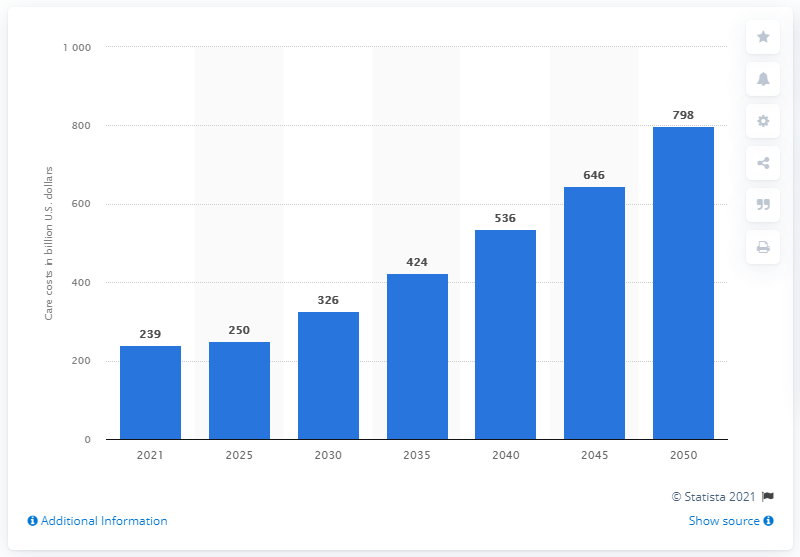Give some essential details in this illustration. In 2021, the cost of Alzheimer's disease to Medicare and Medicaid was $239 billion. By 2050, the estimated cost of Alzheimer's care to Medicare and Medicaid is projected to be $798 billion. 